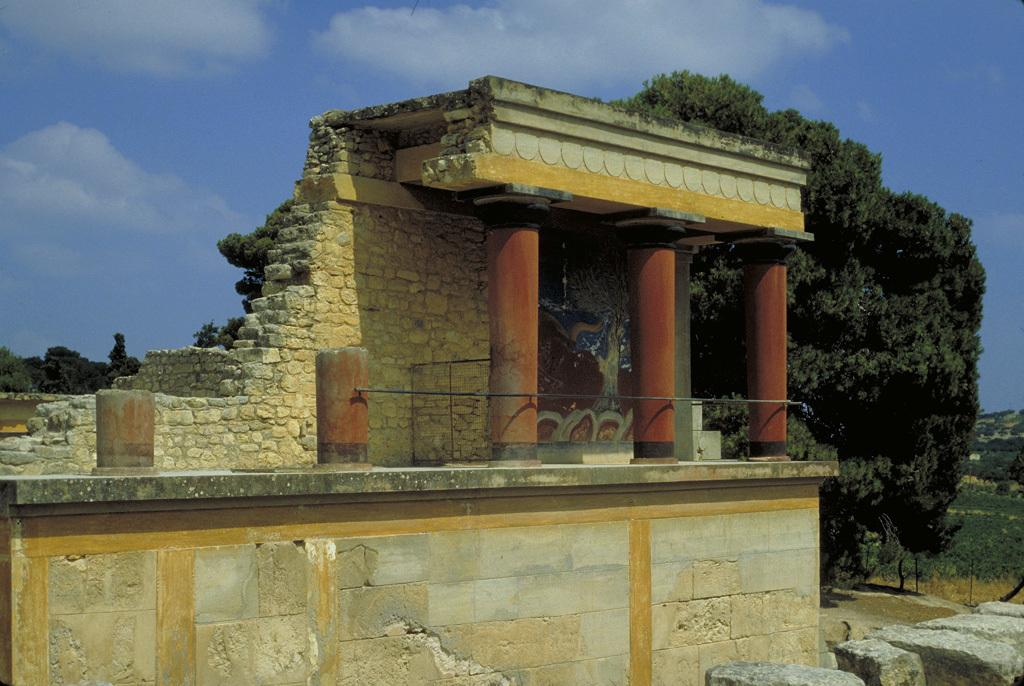What type of structure can be seen in the image? There is a wall in the image. Are there any architectural features present in the image? Yes, there are pillars in the image. What type of vegetation is visible in the image? There are trees in the image. What type of material is present in the image? There are stones in the image. What is visible in the background of the image? The sky is visible in the image. How many girls are sitting on the branch in the image? There are no girls or branches present in the image. 